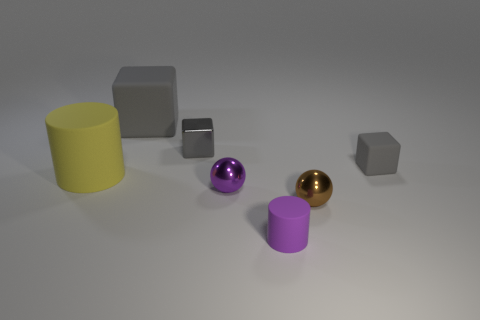What number of other things are the same shape as the gray shiny thing?
Provide a short and direct response. 2. Is there any other thing that has the same color as the small matte cylinder?
Your answer should be compact. Yes. There is a large cylinder; does it have the same color as the small rubber thing that is in front of the small rubber block?
Keep it short and to the point. No. How many other things are there of the same size as the gray metal thing?
Provide a succinct answer. 4. The shiny block that is the same color as the small matte cube is what size?
Ensure brevity in your answer.  Small. How many balls are either yellow things or gray matte objects?
Provide a short and direct response. 0. Do the metal thing that is in front of the purple metal thing and the tiny purple metallic object have the same shape?
Make the answer very short. Yes. Is the number of balls in front of the purple sphere greater than the number of big red matte balls?
Your answer should be compact. Yes. What color is the metal cube that is the same size as the purple matte thing?
Ensure brevity in your answer.  Gray. What number of things are either small purple things left of the tiny brown ball or gray things?
Offer a terse response. 5. 